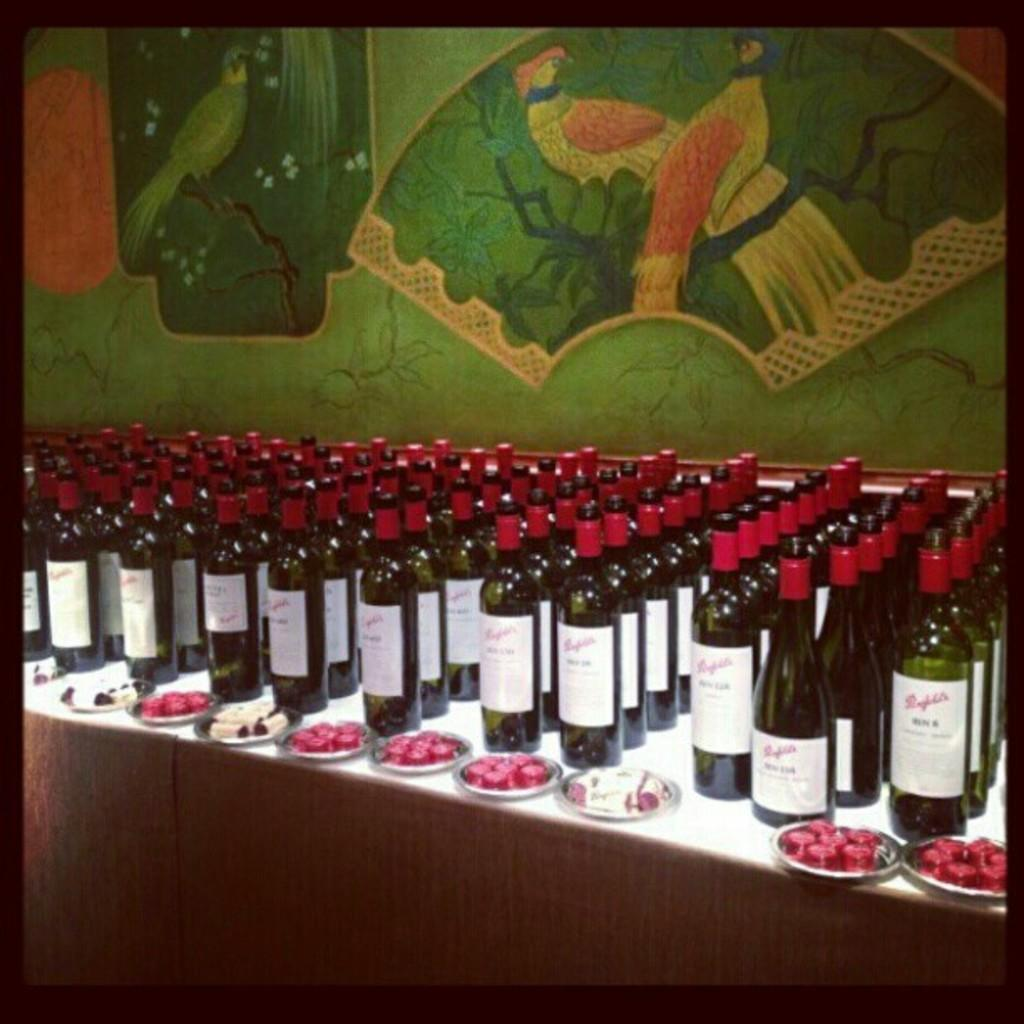What is the main object on the table in the image? There are many wine bottles on the table in the image. What else can be seen on the table besides the wine bottles? There is a plate on the table. What color are the wine bottle caps? The wine bottle caps are red. What color is the wall visible in the image? There is a green wall at the back side of the image. How many teeth can be seen in the image? There are no teeth visible in the image. What is needed to open the wine bottles in the image? The question does not specify any tools or methods for opening the wine bottles, so it cannot be answered definitively. 